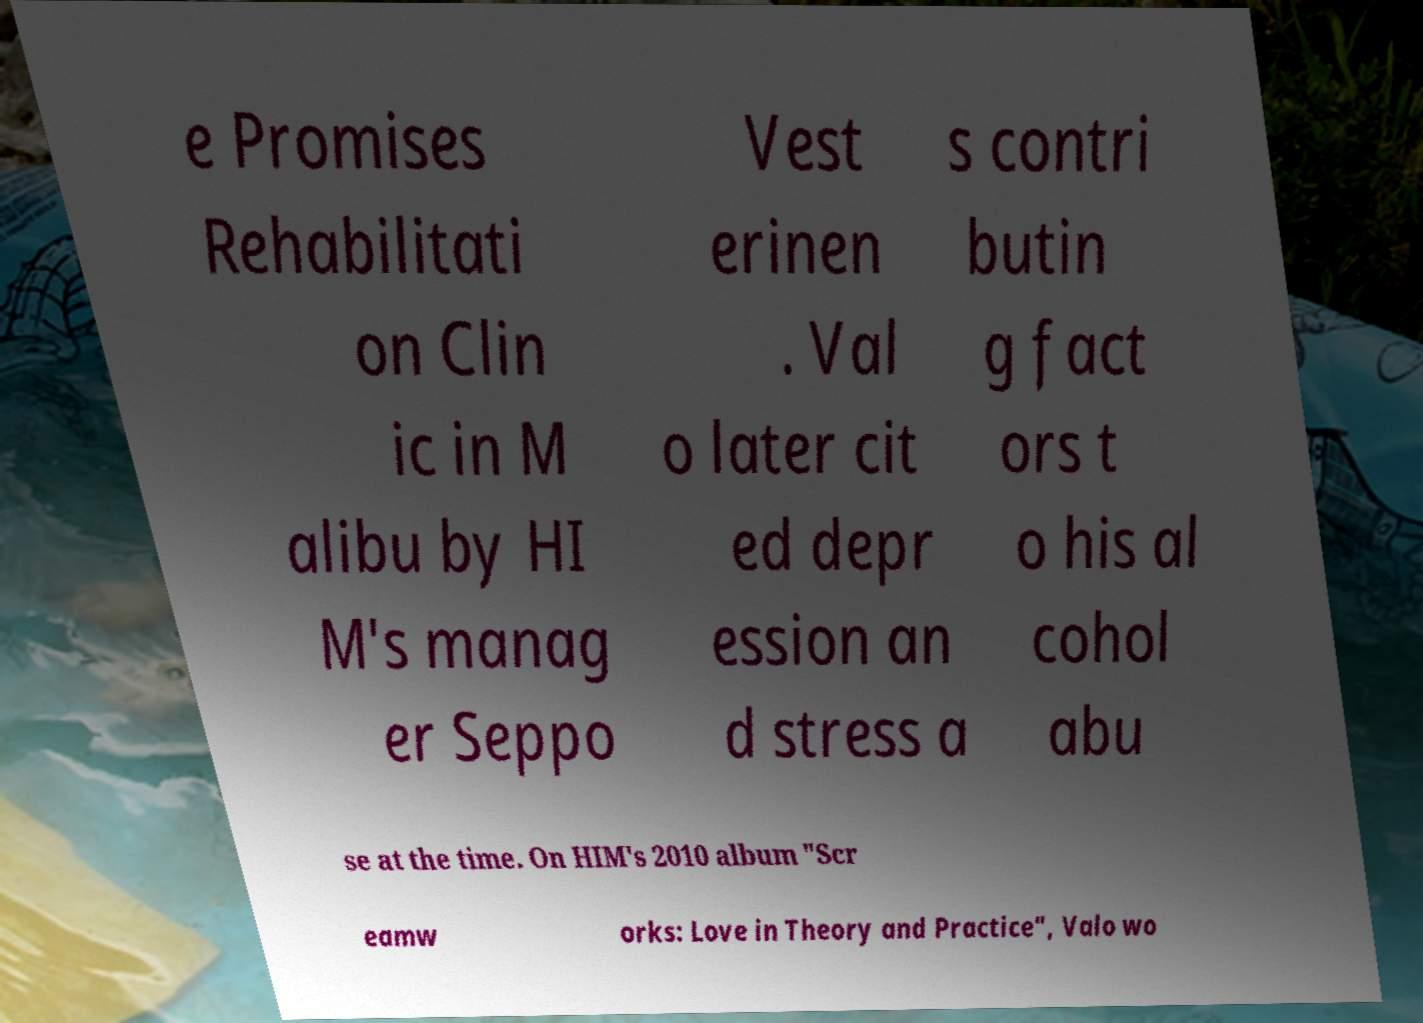Could you assist in decoding the text presented in this image and type it out clearly? e Promises Rehabilitati on Clin ic in M alibu by HI M's manag er Seppo Vest erinen . Val o later cit ed depr ession an d stress a s contri butin g fact ors t o his al cohol abu se at the time. On HIM's 2010 album "Scr eamw orks: Love in Theory and Practice", Valo wo 